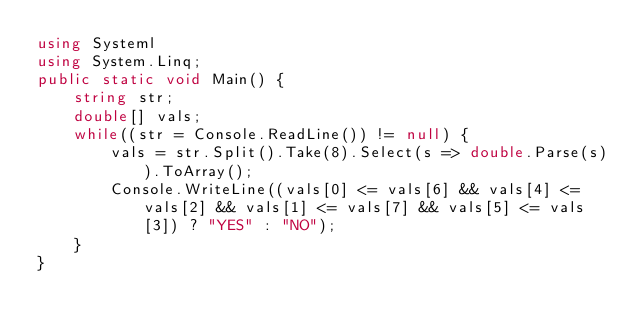Convert code to text. <code><loc_0><loc_0><loc_500><loc_500><_C#_>using Systeml
using System.Linq;
public static void Main() {
	string str;
	double[] vals;
	while((str = Console.ReadLine()) != null) {
		vals = str.Split().Take(8).Select(s => double.Parse(s)).ToArray();
		Console.WriteLine((vals[0] <= vals[6] && vals[4] <= vals[2] && vals[1] <= vals[7] && vals[5] <= vals[3]) ? "YES" : "NO");
	}
}</code> 